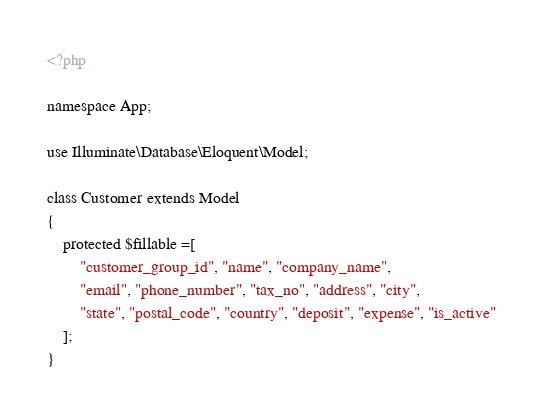Convert code to text. <code><loc_0><loc_0><loc_500><loc_500><_PHP_><?php

namespace App;

use Illuminate\Database\Eloquent\Model;

class Customer extends Model
{
    protected $fillable =[
        "customer_group_id", "name", "company_name",
        "email", "phone_number", "tax_no", "address", "city",
        "state", "postal_code", "country", "deposit", "expense", "is_active"
    ];
}
</code> 